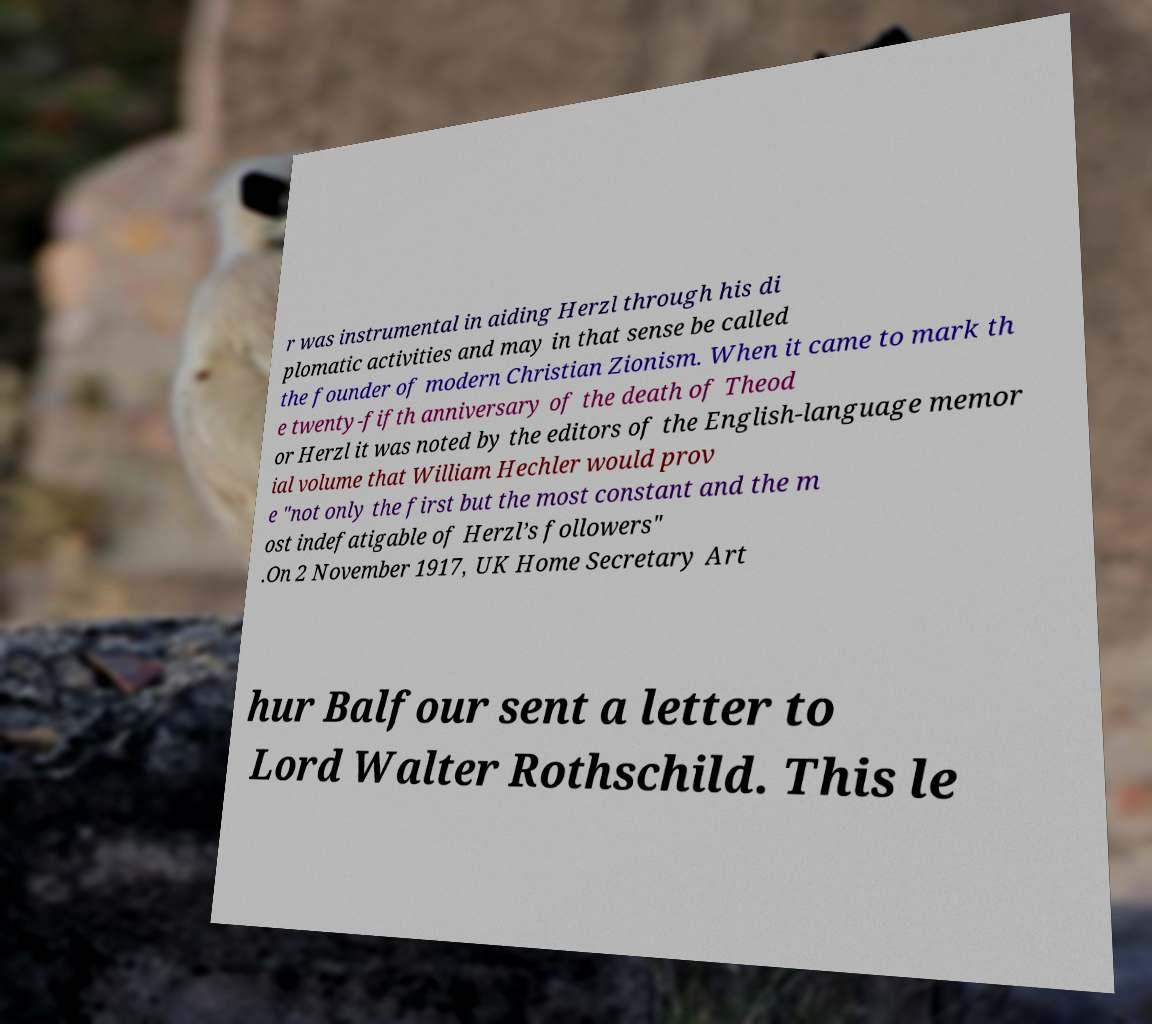Please identify and transcribe the text found in this image. r was instrumental in aiding Herzl through his di plomatic activities and may in that sense be called the founder of modern Christian Zionism. When it came to mark th e twenty-fifth anniversary of the death of Theod or Herzl it was noted by the editors of the English-language memor ial volume that William Hechler would prov e "not only the first but the most constant and the m ost indefatigable of Herzl’s followers" .On 2 November 1917, UK Home Secretary Art hur Balfour sent a letter to Lord Walter Rothschild. This le 